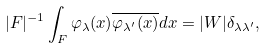Convert formula to latex. <formula><loc_0><loc_0><loc_500><loc_500>| F | ^ { - 1 } \int _ { F } \varphi _ { \lambda } ( x ) \overline { \varphi _ { \lambda ^ { \prime } } ( x ) } d x = | W | \delta _ { \lambda \lambda ^ { \prime } } ,</formula> 